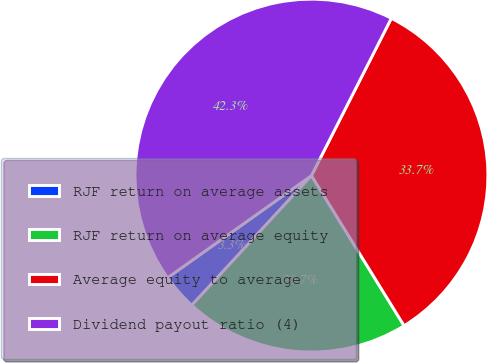Convert chart. <chart><loc_0><loc_0><loc_500><loc_500><pie_chart><fcel>RJF return on average assets<fcel>RJF return on average equity<fcel>Average equity to average<fcel>Dividend payout ratio (4)<nl><fcel>3.31%<fcel>20.66%<fcel>33.72%<fcel>42.3%<nl></chart> 